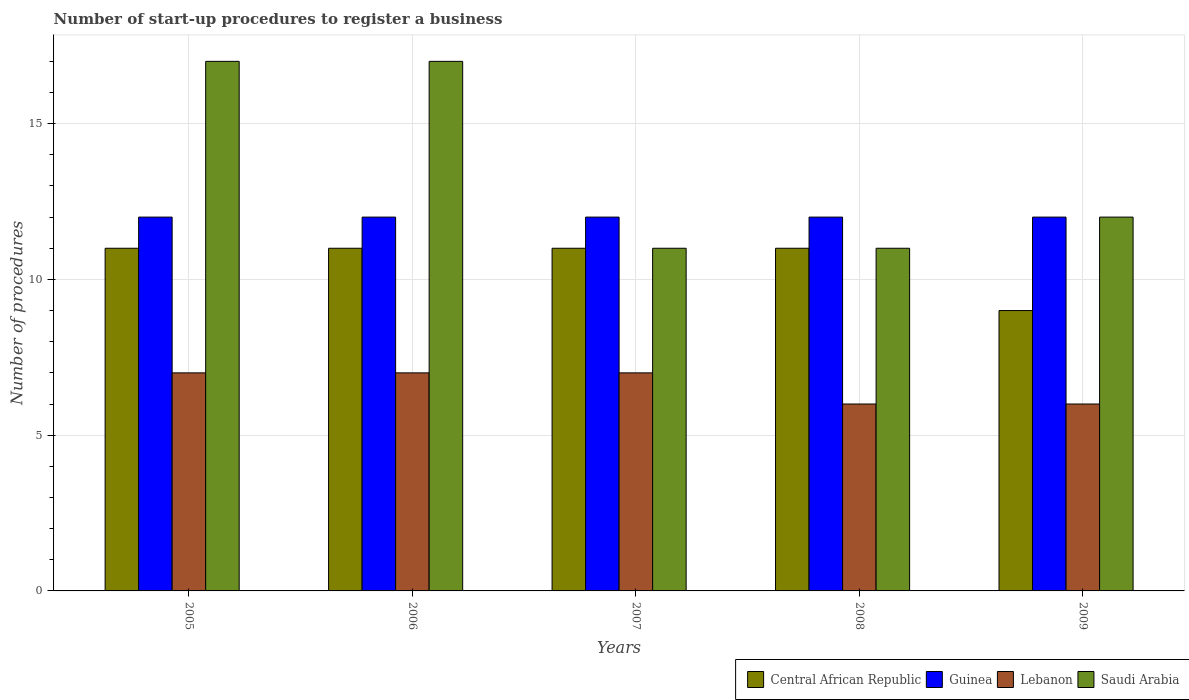How many different coloured bars are there?
Offer a terse response. 4. How many groups of bars are there?
Give a very brief answer. 5. Are the number of bars per tick equal to the number of legend labels?
Make the answer very short. Yes. How many bars are there on the 4th tick from the left?
Keep it short and to the point. 4. How many bars are there on the 3rd tick from the right?
Make the answer very short. 4. What is the number of procedures required to register a business in Central African Republic in 2008?
Give a very brief answer. 11. Across all years, what is the maximum number of procedures required to register a business in Guinea?
Your response must be concise. 12. Across all years, what is the minimum number of procedures required to register a business in Guinea?
Make the answer very short. 12. In which year was the number of procedures required to register a business in Lebanon maximum?
Keep it short and to the point. 2005. In which year was the number of procedures required to register a business in Central African Republic minimum?
Keep it short and to the point. 2009. What is the total number of procedures required to register a business in Guinea in the graph?
Provide a short and direct response. 60. What is the difference between the number of procedures required to register a business in Guinea in 2006 and that in 2007?
Keep it short and to the point. 0. What is the difference between the number of procedures required to register a business in Lebanon in 2008 and the number of procedures required to register a business in Guinea in 2009?
Your response must be concise. -6. In the year 2008, what is the difference between the number of procedures required to register a business in Lebanon and number of procedures required to register a business in Guinea?
Keep it short and to the point. -6. In how many years, is the number of procedures required to register a business in Saudi Arabia greater than 10?
Make the answer very short. 5. What is the ratio of the number of procedures required to register a business in Saudi Arabia in 2005 to that in 2008?
Make the answer very short. 1.55. Is the difference between the number of procedures required to register a business in Lebanon in 2006 and 2008 greater than the difference between the number of procedures required to register a business in Guinea in 2006 and 2008?
Provide a succinct answer. Yes. What is the difference between the highest and the second highest number of procedures required to register a business in Guinea?
Your response must be concise. 0. In how many years, is the number of procedures required to register a business in Saudi Arabia greater than the average number of procedures required to register a business in Saudi Arabia taken over all years?
Provide a short and direct response. 2. Is it the case that in every year, the sum of the number of procedures required to register a business in Lebanon and number of procedures required to register a business in Saudi Arabia is greater than the sum of number of procedures required to register a business in Guinea and number of procedures required to register a business in Central African Republic?
Offer a very short reply. No. What does the 3rd bar from the left in 2005 represents?
Offer a terse response. Lebanon. What does the 1st bar from the right in 2007 represents?
Offer a very short reply. Saudi Arabia. Are the values on the major ticks of Y-axis written in scientific E-notation?
Make the answer very short. No. Does the graph contain grids?
Your answer should be very brief. Yes. Where does the legend appear in the graph?
Your response must be concise. Bottom right. What is the title of the graph?
Keep it short and to the point. Number of start-up procedures to register a business. Does "Kiribati" appear as one of the legend labels in the graph?
Ensure brevity in your answer.  No. What is the label or title of the Y-axis?
Give a very brief answer. Number of procedures. What is the Number of procedures in Central African Republic in 2005?
Provide a short and direct response. 11. What is the Number of procedures in Saudi Arabia in 2005?
Provide a succinct answer. 17. What is the Number of procedures of Central African Republic in 2006?
Your answer should be compact. 11. What is the Number of procedures of Lebanon in 2006?
Your response must be concise. 7. What is the Number of procedures of Saudi Arabia in 2006?
Keep it short and to the point. 17. What is the Number of procedures of Central African Republic in 2007?
Keep it short and to the point. 11. What is the Number of procedures of Guinea in 2007?
Provide a short and direct response. 12. What is the Number of procedures in Saudi Arabia in 2007?
Offer a terse response. 11. What is the Number of procedures of Guinea in 2008?
Offer a very short reply. 12. What is the Number of procedures of Central African Republic in 2009?
Provide a succinct answer. 9. What is the Number of procedures of Lebanon in 2009?
Your answer should be compact. 6. What is the Number of procedures of Saudi Arabia in 2009?
Your answer should be very brief. 12. Across all years, what is the maximum Number of procedures in Guinea?
Your response must be concise. 12. Across all years, what is the maximum Number of procedures in Lebanon?
Provide a short and direct response. 7. Across all years, what is the minimum Number of procedures in Guinea?
Your response must be concise. 12. What is the total Number of procedures of Central African Republic in the graph?
Your response must be concise. 53. What is the total Number of procedures of Guinea in the graph?
Your answer should be very brief. 60. What is the difference between the Number of procedures of Central African Republic in 2005 and that in 2006?
Provide a short and direct response. 0. What is the difference between the Number of procedures in Saudi Arabia in 2005 and that in 2006?
Your answer should be compact. 0. What is the difference between the Number of procedures in Guinea in 2005 and that in 2008?
Your response must be concise. 0. What is the difference between the Number of procedures of Saudi Arabia in 2005 and that in 2008?
Make the answer very short. 6. What is the difference between the Number of procedures of Guinea in 2005 and that in 2009?
Your answer should be compact. 0. What is the difference between the Number of procedures in Lebanon in 2006 and that in 2007?
Provide a short and direct response. 0. What is the difference between the Number of procedures of Saudi Arabia in 2006 and that in 2007?
Your answer should be very brief. 6. What is the difference between the Number of procedures of Guinea in 2006 and that in 2008?
Make the answer very short. 0. What is the difference between the Number of procedures in Guinea in 2006 and that in 2009?
Ensure brevity in your answer.  0. What is the difference between the Number of procedures of Lebanon in 2006 and that in 2009?
Ensure brevity in your answer.  1. What is the difference between the Number of procedures in Saudi Arabia in 2006 and that in 2009?
Provide a succinct answer. 5. What is the difference between the Number of procedures of Guinea in 2007 and that in 2009?
Make the answer very short. 0. What is the difference between the Number of procedures in Lebanon in 2007 and that in 2009?
Your response must be concise. 1. What is the difference between the Number of procedures in Lebanon in 2008 and that in 2009?
Ensure brevity in your answer.  0. What is the difference between the Number of procedures in Central African Republic in 2005 and the Number of procedures in Guinea in 2006?
Offer a very short reply. -1. What is the difference between the Number of procedures in Central African Republic in 2005 and the Number of procedures in Saudi Arabia in 2006?
Ensure brevity in your answer.  -6. What is the difference between the Number of procedures in Lebanon in 2005 and the Number of procedures in Saudi Arabia in 2006?
Your answer should be compact. -10. What is the difference between the Number of procedures of Central African Republic in 2005 and the Number of procedures of Saudi Arabia in 2007?
Keep it short and to the point. 0. What is the difference between the Number of procedures in Guinea in 2005 and the Number of procedures in Lebanon in 2007?
Your answer should be compact. 5. What is the difference between the Number of procedures in Central African Republic in 2005 and the Number of procedures in Guinea in 2008?
Your answer should be compact. -1. What is the difference between the Number of procedures in Guinea in 2005 and the Number of procedures in Saudi Arabia in 2008?
Ensure brevity in your answer.  1. What is the difference between the Number of procedures in Lebanon in 2005 and the Number of procedures in Saudi Arabia in 2008?
Offer a very short reply. -4. What is the difference between the Number of procedures of Central African Republic in 2005 and the Number of procedures of Lebanon in 2009?
Ensure brevity in your answer.  5. What is the difference between the Number of procedures in Central African Republic in 2006 and the Number of procedures in Lebanon in 2007?
Offer a very short reply. 4. What is the difference between the Number of procedures in Central African Republic in 2006 and the Number of procedures in Saudi Arabia in 2007?
Offer a very short reply. 0. What is the difference between the Number of procedures of Guinea in 2006 and the Number of procedures of Lebanon in 2008?
Give a very brief answer. 6. What is the difference between the Number of procedures in Guinea in 2006 and the Number of procedures in Saudi Arabia in 2008?
Provide a succinct answer. 1. What is the difference between the Number of procedures in Central African Republic in 2006 and the Number of procedures in Guinea in 2009?
Offer a terse response. -1. What is the difference between the Number of procedures in Central African Republic in 2006 and the Number of procedures in Lebanon in 2009?
Ensure brevity in your answer.  5. What is the difference between the Number of procedures in Central African Republic in 2006 and the Number of procedures in Saudi Arabia in 2009?
Offer a very short reply. -1. What is the difference between the Number of procedures in Guinea in 2006 and the Number of procedures in Saudi Arabia in 2009?
Make the answer very short. 0. What is the difference between the Number of procedures of Lebanon in 2006 and the Number of procedures of Saudi Arabia in 2009?
Offer a very short reply. -5. What is the difference between the Number of procedures of Central African Republic in 2007 and the Number of procedures of Guinea in 2008?
Keep it short and to the point. -1. What is the difference between the Number of procedures in Guinea in 2007 and the Number of procedures in Lebanon in 2008?
Provide a succinct answer. 6. What is the difference between the Number of procedures of Lebanon in 2007 and the Number of procedures of Saudi Arabia in 2008?
Your response must be concise. -4. What is the difference between the Number of procedures of Central African Republic in 2007 and the Number of procedures of Guinea in 2009?
Ensure brevity in your answer.  -1. What is the difference between the Number of procedures of Central African Republic in 2007 and the Number of procedures of Saudi Arabia in 2009?
Offer a very short reply. -1. What is the difference between the Number of procedures of Central African Republic in 2008 and the Number of procedures of Guinea in 2009?
Ensure brevity in your answer.  -1. What is the difference between the Number of procedures of Central African Republic in 2008 and the Number of procedures of Lebanon in 2009?
Make the answer very short. 5. What is the difference between the Number of procedures of Central African Republic in 2008 and the Number of procedures of Saudi Arabia in 2009?
Offer a terse response. -1. What is the difference between the Number of procedures in Guinea in 2008 and the Number of procedures in Lebanon in 2009?
Your answer should be very brief. 6. What is the difference between the Number of procedures in Guinea in 2008 and the Number of procedures in Saudi Arabia in 2009?
Ensure brevity in your answer.  0. What is the average Number of procedures in Central African Republic per year?
Offer a terse response. 10.6. What is the average Number of procedures of Guinea per year?
Give a very brief answer. 12. In the year 2005, what is the difference between the Number of procedures in Central African Republic and Number of procedures in Lebanon?
Offer a terse response. 4. In the year 2005, what is the difference between the Number of procedures in Guinea and Number of procedures in Saudi Arabia?
Provide a succinct answer. -5. In the year 2005, what is the difference between the Number of procedures of Lebanon and Number of procedures of Saudi Arabia?
Keep it short and to the point. -10. In the year 2006, what is the difference between the Number of procedures of Central African Republic and Number of procedures of Guinea?
Offer a very short reply. -1. In the year 2006, what is the difference between the Number of procedures in Lebanon and Number of procedures in Saudi Arabia?
Your answer should be compact. -10. In the year 2007, what is the difference between the Number of procedures of Guinea and Number of procedures of Saudi Arabia?
Your answer should be compact. 1. In the year 2007, what is the difference between the Number of procedures of Lebanon and Number of procedures of Saudi Arabia?
Your answer should be very brief. -4. In the year 2008, what is the difference between the Number of procedures in Central African Republic and Number of procedures in Lebanon?
Provide a short and direct response. 5. In the year 2008, what is the difference between the Number of procedures of Central African Republic and Number of procedures of Saudi Arabia?
Your answer should be very brief. 0. In the year 2008, what is the difference between the Number of procedures in Guinea and Number of procedures in Lebanon?
Offer a very short reply. 6. In the year 2008, what is the difference between the Number of procedures in Lebanon and Number of procedures in Saudi Arabia?
Give a very brief answer. -5. In the year 2009, what is the difference between the Number of procedures in Central African Republic and Number of procedures in Guinea?
Ensure brevity in your answer.  -3. In the year 2009, what is the difference between the Number of procedures of Central African Republic and Number of procedures of Lebanon?
Offer a very short reply. 3. In the year 2009, what is the difference between the Number of procedures of Central African Republic and Number of procedures of Saudi Arabia?
Provide a short and direct response. -3. In the year 2009, what is the difference between the Number of procedures of Guinea and Number of procedures of Lebanon?
Ensure brevity in your answer.  6. In the year 2009, what is the difference between the Number of procedures in Guinea and Number of procedures in Saudi Arabia?
Your answer should be compact. 0. In the year 2009, what is the difference between the Number of procedures of Lebanon and Number of procedures of Saudi Arabia?
Make the answer very short. -6. What is the ratio of the Number of procedures in Central African Republic in 2005 to that in 2006?
Give a very brief answer. 1. What is the ratio of the Number of procedures of Guinea in 2005 to that in 2006?
Make the answer very short. 1. What is the ratio of the Number of procedures of Saudi Arabia in 2005 to that in 2007?
Your response must be concise. 1.55. What is the ratio of the Number of procedures in Central African Republic in 2005 to that in 2008?
Give a very brief answer. 1. What is the ratio of the Number of procedures of Guinea in 2005 to that in 2008?
Provide a short and direct response. 1. What is the ratio of the Number of procedures of Lebanon in 2005 to that in 2008?
Offer a very short reply. 1.17. What is the ratio of the Number of procedures in Saudi Arabia in 2005 to that in 2008?
Provide a succinct answer. 1.55. What is the ratio of the Number of procedures of Central African Republic in 2005 to that in 2009?
Offer a terse response. 1.22. What is the ratio of the Number of procedures in Saudi Arabia in 2005 to that in 2009?
Offer a very short reply. 1.42. What is the ratio of the Number of procedures of Central African Republic in 2006 to that in 2007?
Make the answer very short. 1. What is the ratio of the Number of procedures of Lebanon in 2006 to that in 2007?
Your response must be concise. 1. What is the ratio of the Number of procedures of Saudi Arabia in 2006 to that in 2007?
Provide a short and direct response. 1.55. What is the ratio of the Number of procedures of Guinea in 2006 to that in 2008?
Your answer should be compact. 1. What is the ratio of the Number of procedures in Saudi Arabia in 2006 to that in 2008?
Offer a very short reply. 1.55. What is the ratio of the Number of procedures of Central African Republic in 2006 to that in 2009?
Provide a succinct answer. 1.22. What is the ratio of the Number of procedures of Saudi Arabia in 2006 to that in 2009?
Your answer should be compact. 1.42. What is the ratio of the Number of procedures of Lebanon in 2007 to that in 2008?
Ensure brevity in your answer.  1.17. What is the ratio of the Number of procedures of Central African Republic in 2007 to that in 2009?
Your answer should be compact. 1.22. What is the ratio of the Number of procedures in Guinea in 2007 to that in 2009?
Your answer should be very brief. 1. What is the ratio of the Number of procedures of Saudi Arabia in 2007 to that in 2009?
Your answer should be compact. 0.92. What is the ratio of the Number of procedures in Central African Republic in 2008 to that in 2009?
Provide a short and direct response. 1.22. What is the ratio of the Number of procedures of Lebanon in 2008 to that in 2009?
Make the answer very short. 1. What is the difference between the highest and the second highest Number of procedures in Central African Republic?
Keep it short and to the point. 0. What is the difference between the highest and the second highest Number of procedures of Guinea?
Your answer should be very brief. 0. What is the difference between the highest and the second highest Number of procedures of Saudi Arabia?
Your answer should be compact. 0. What is the difference between the highest and the lowest Number of procedures of Guinea?
Your answer should be compact. 0. What is the difference between the highest and the lowest Number of procedures in Saudi Arabia?
Make the answer very short. 6. 